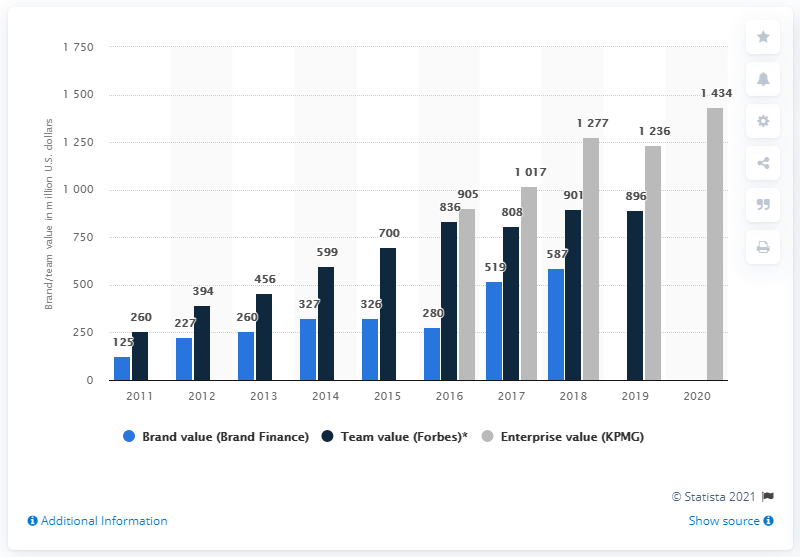Draw attention to some important aspects in this diagram. In 2019, Borussia Dortmund's team value was reported to be 896 million U.S. dollars. 